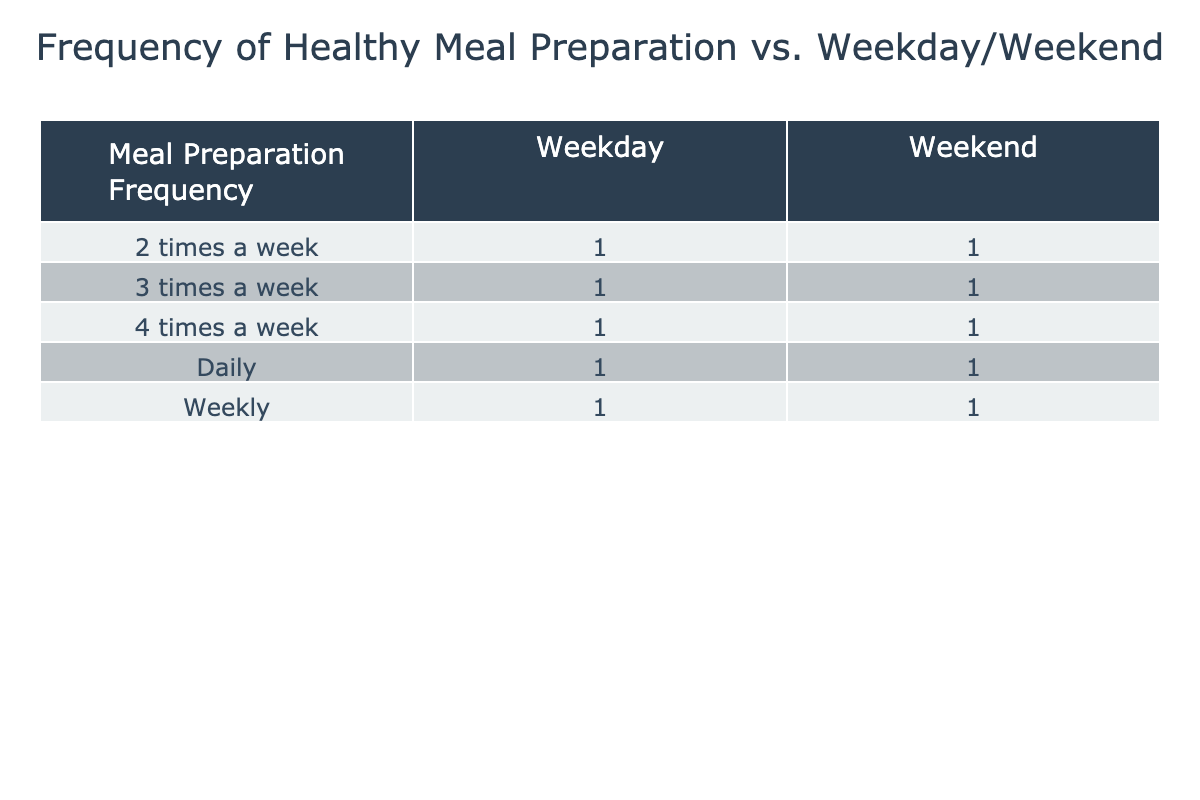What is the most common frequency of healthy meal preparation for weekdays? The table shows the meal preparation frequencies categorized by weekdays. By reviewing the counts in the 'Weekday' column, 'Daily' appears to have the highest frequency with a count of 1.
Answer: Daily How many times did people prepare healthy meals weekly on weekends? Looking at the 'Weekend' column, each frequency counts as follows: 'Daily' (1), '4 times a week' (1), '3 times a week' (1), '2 times a week' (1), and 'Weekly' (1). Summing these gives 5 total counts for the 'Weekend' column.
Answer: 5 Is meal preparation frequency higher on weekdays or weekends? We can compare the total values for both weekdays and weekends. The total counts for weekdays are: 'Daily' (1), '4 times a week' (1), '3 times a week' (1), '2 times a week' (1), 'Weekly' (1) totaling to 5, while weekends also total 5 ('Daily' (1), '4 times a week' (1), '3 times a week' (1), '2 times a week' (1), and 'Weekly' (1)). Since they are equal, the answer is no difference.
Answer: No difference How many people prepare healthy meals 3 times a week for weekdays? Referring to the 'Weekday' column, only one entry is listed under '3 times a week' which directly corresponds to a count of 1.
Answer: 1 What is the difference between the number of times healthy meals are prepared weekly on weekdays compared to weekends? From the table, the count for 'Weekly' for weekdays is 1 and for weekends is also 1. Thus, the difference is 1 - 1 = 0.
Answer: 0 Do more people prepare healthy meals daily than weekly on weekdays? 'Daily' under weekdays has a count of 1 while 'Weekly' has a count of 1 too. Therefore, both are equal in frequency.
Answer: No What percentage of the total meal preparation is for '4 times a week' on weekdays? The counts for weekdays total 5. The count for '4 times a week' is 1. So, the percentage is (1/5) * 100 = 20%.
Answer: 20% Which meal preparation frequency is least common on weekends? In the weekend categories, all frequencies ('Daily', '4 times a week', '3 times a week', '2 times a week', 'Weekly') each have a count of 1. Hence, there is no unique least common frequency; they are all equal.
Answer: All are equal 